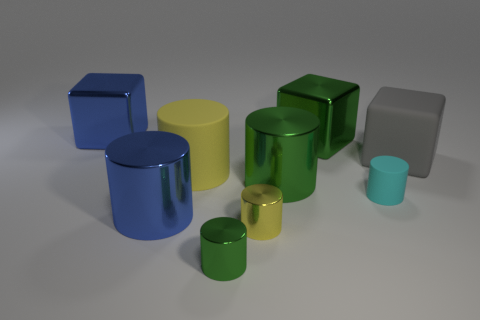How many green cylinders must be subtracted to get 1 green cylinders? 1 Subtract all large green metal cubes. How many cubes are left? 2 Add 1 matte spheres. How many objects exist? 10 Subtract all yellow cylinders. How many cylinders are left? 4 Subtract all blocks. How many objects are left? 6 Subtract all blue balls. How many green cylinders are left? 2 Subtract all large rubber cubes. Subtract all big matte balls. How many objects are left? 8 Add 2 tiny yellow objects. How many tiny yellow objects are left? 3 Add 5 blue metal objects. How many blue metal objects exist? 7 Subtract 2 yellow cylinders. How many objects are left? 7 